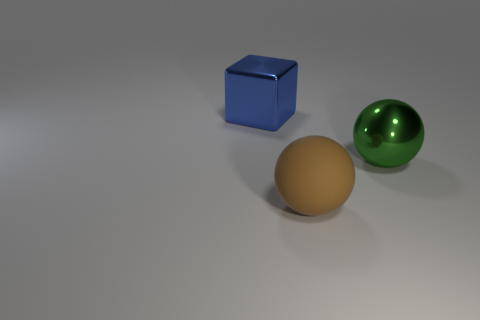Add 3 brown matte objects. How many objects exist? 6 Subtract all balls. How many objects are left? 1 Add 3 large brown rubber things. How many large brown rubber things are left? 4 Add 2 small purple matte balls. How many small purple matte balls exist? 2 Subtract 0 yellow cubes. How many objects are left? 3 Subtract all big brown matte balls. Subtract all small shiny cylinders. How many objects are left? 2 